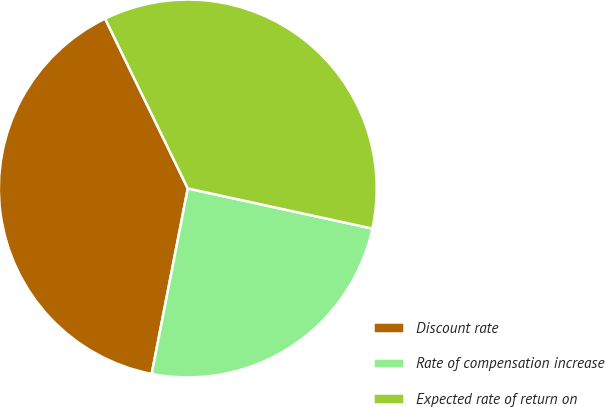Convert chart. <chart><loc_0><loc_0><loc_500><loc_500><pie_chart><fcel>Discount rate<fcel>Rate of compensation increase<fcel>Expected rate of return on<nl><fcel>39.73%<fcel>24.66%<fcel>35.62%<nl></chart> 